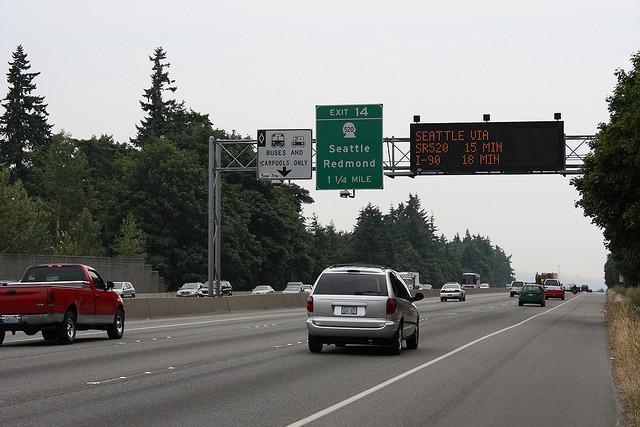How many cars are in the express lane?
Give a very brief answer. 1. How many cars are in the picture?
Give a very brief answer. 2. How many clock faces do you see?
Give a very brief answer. 0. 